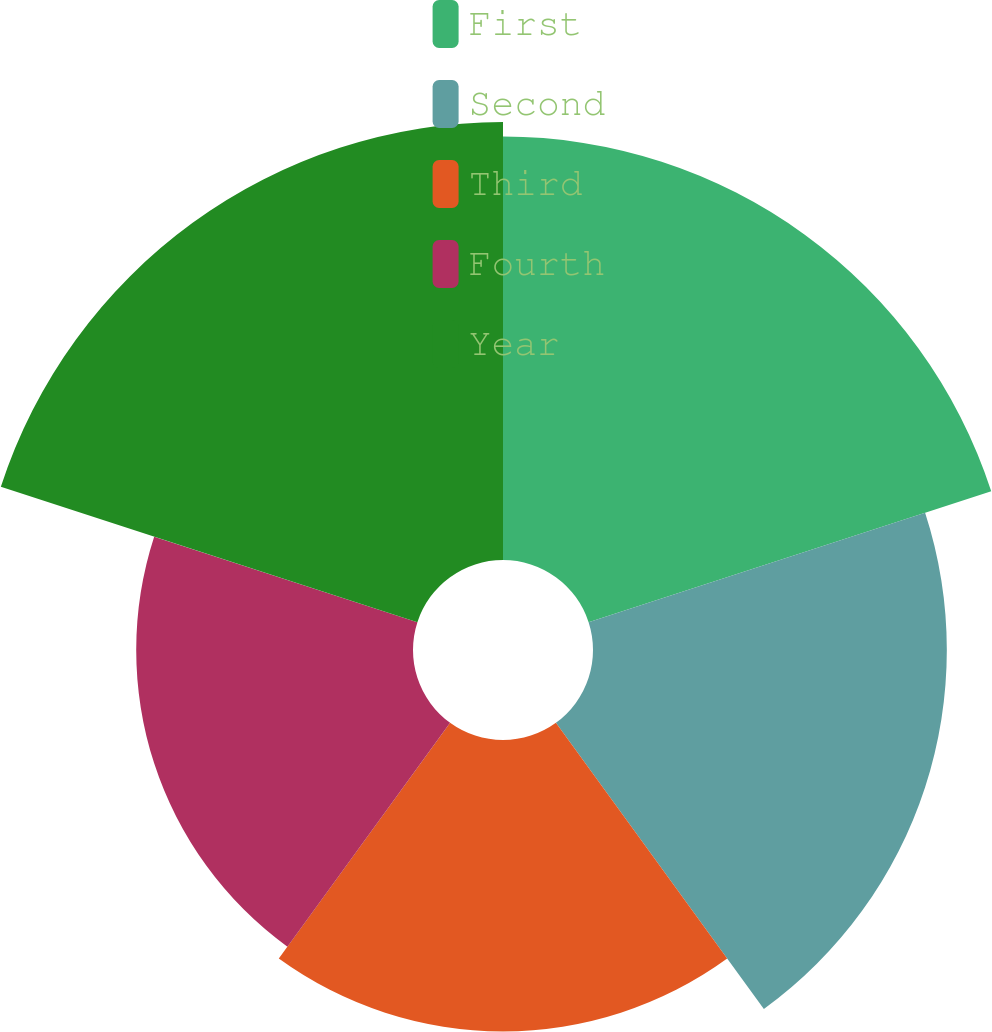Convert chart to OTSL. <chart><loc_0><loc_0><loc_500><loc_500><pie_chart><fcel>First<fcel>Second<fcel>Third<fcel>Fourth<fcel>Year<nl><fcel>23.74%<fcel>19.84%<fcel>16.34%<fcel>15.52%<fcel>24.56%<nl></chart> 